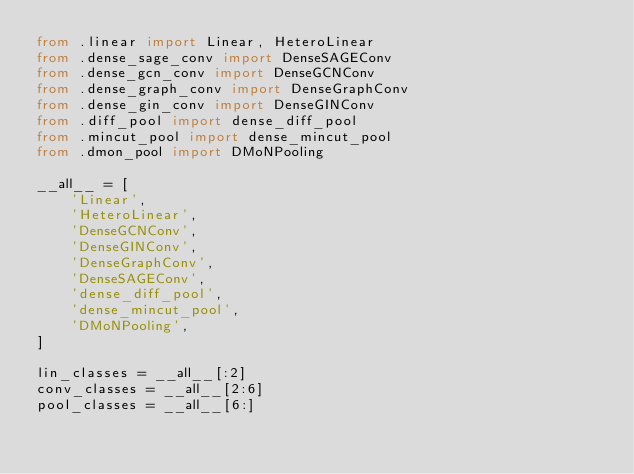Convert code to text. <code><loc_0><loc_0><loc_500><loc_500><_Python_>from .linear import Linear, HeteroLinear
from .dense_sage_conv import DenseSAGEConv
from .dense_gcn_conv import DenseGCNConv
from .dense_graph_conv import DenseGraphConv
from .dense_gin_conv import DenseGINConv
from .diff_pool import dense_diff_pool
from .mincut_pool import dense_mincut_pool
from .dmon_pool import DMoNPooling

__all__ = [
    'Linear',
    'HeteroLinear',
    'DenseGCNConv',
    'DenseGINConv',
    'DenseGraphConv',
    'DenseSAGEConv',
    'dense_diff_pool',
    'dense_mincut_pool',
    'DMoNPooling',
]

lin_classes = __all__[:2]
conv_classes = __all__[2:6]
pool_classes = __all__[6:]
</code> 